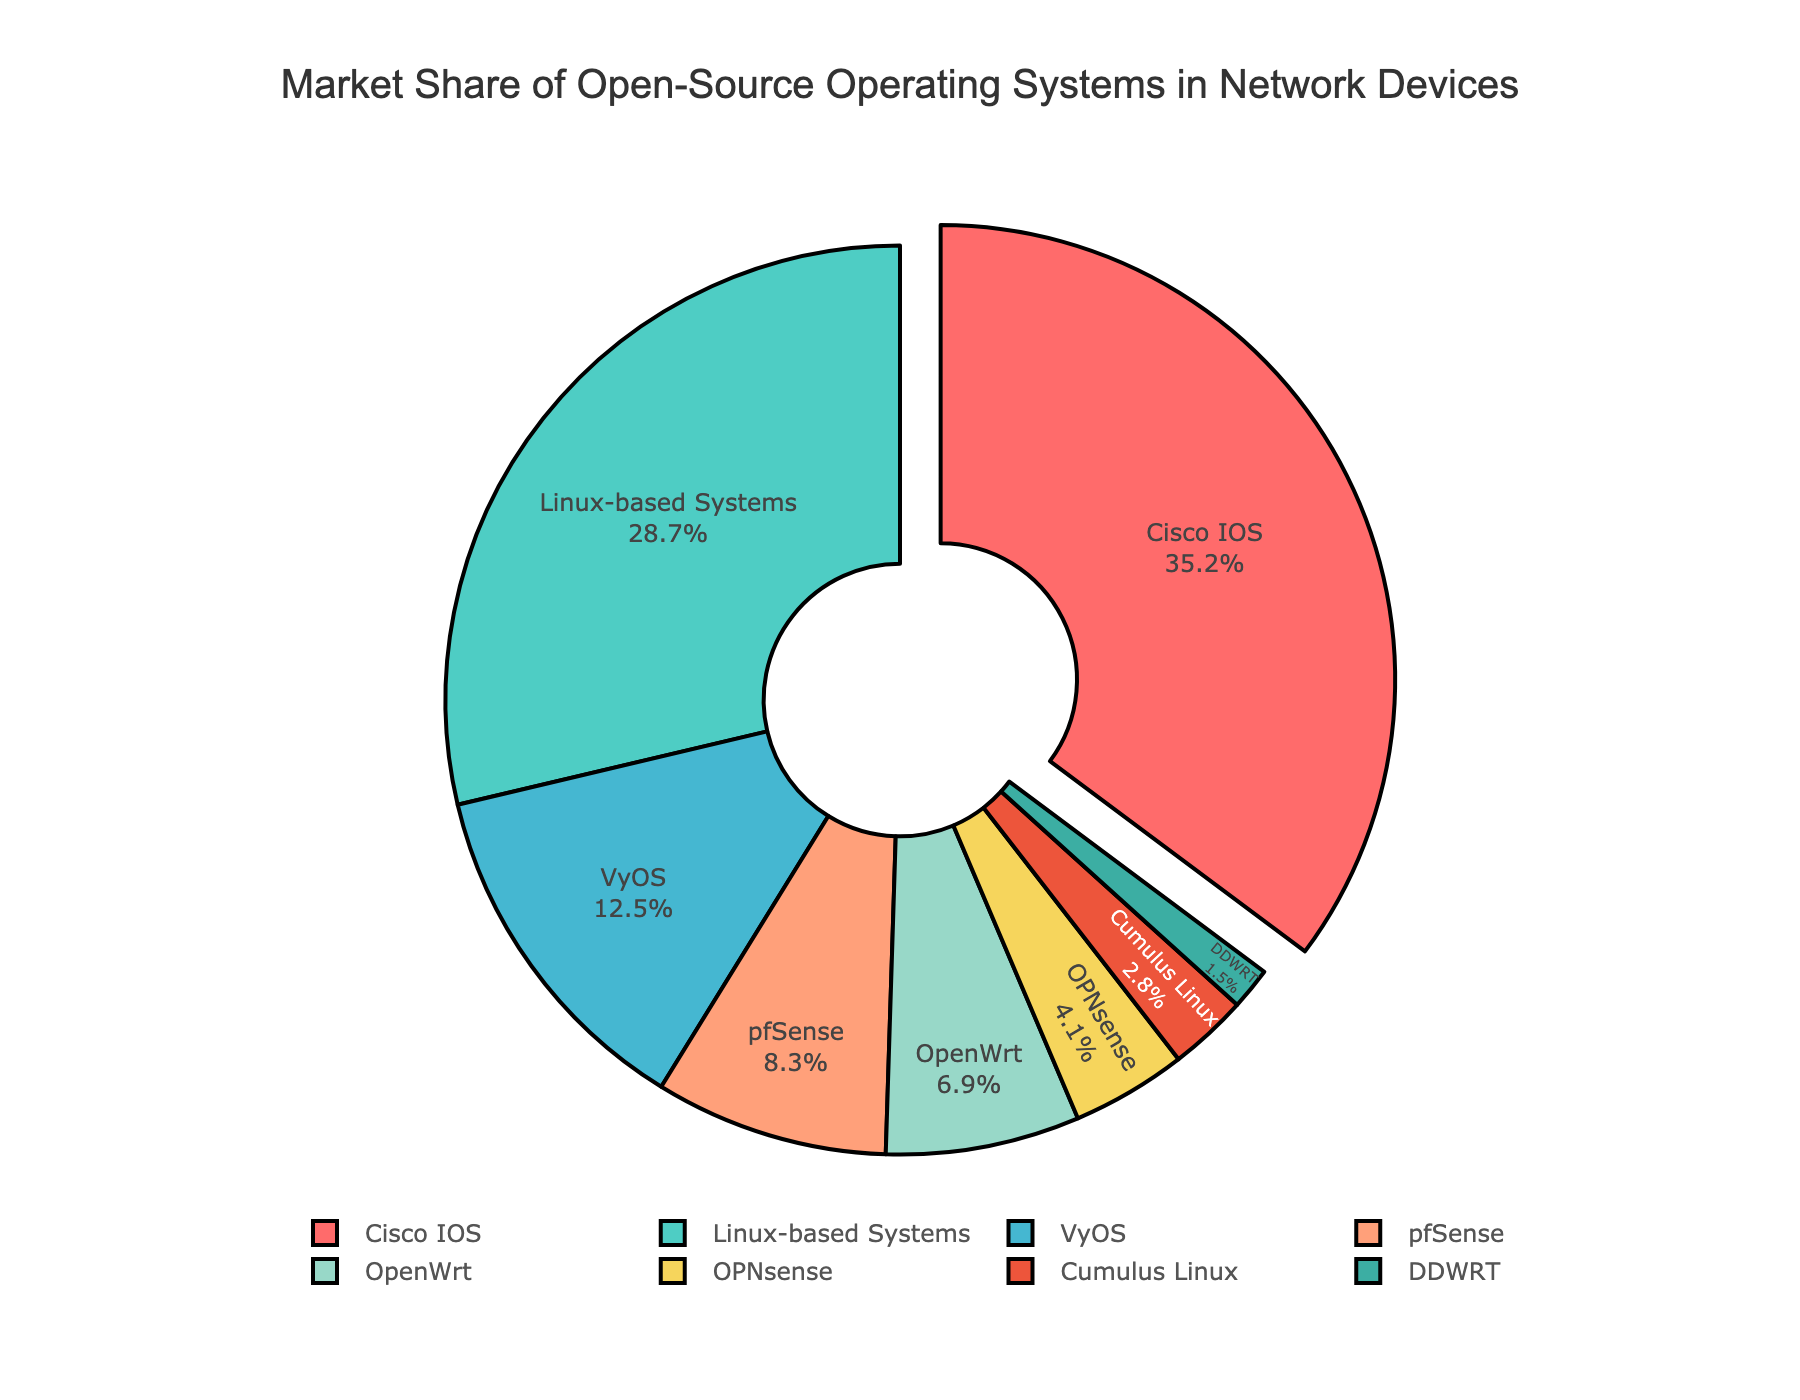What is the market share of the Linux-based Systems? The percentage value next to "Linux-based Systems" in the pie chart is 28.7%.
Answer: 28.7% Which operating system has the highest market share? The slice pulled out from the rest of the pie chart represents the operating system with the highest market share, which is Cisco IOS at 35.2%.
Answer: Cisco IOS What is the combined market share of VyOS and pfSense? To find the combined market share, add the percentages of VyOS (12.5%) and pfSense (8.3%). This gives 12.5 + 8.3 = 20.8%.
Answer: 20.8% Are there more operating systems with a market share greater than or less than 10%? There are three slices with market shares greater than 10% (Cisco IOS, Linux-based Systems, and VyOS) and five slices with market shares less than 10%.
Answer: Less than 10% Which operating system has a larger market share: OpenWrt or OPNsense? Compare the percentages of OpenWrt (6.9%) and OPNsense (4.1%) as shown in the pie chart. Since 6.9 > 4.1, OpenWrt has a larger market share.
Answer: OpenWrt What is the difference in market share between the operating system with the highest share and the operating system with the lowest share? Subtract the market share of the lowest (1.5% for DDWRT) from the highest (35.2% for Cisco IOS), which is 35.2 - 1.5 = 33.7%.
Answer: 33.7% What is the average market share of the listed operating systems? To find the average, add all the market shares (35.2 + 28.7 + 12.5 + 8.3 + 6.9 + 4.1 + 2.8 + 1.5 = 100) and divide by the number of operating systems (8). So, 100 / 8 = 12.5%.
Answer: 12.5% What color represents Cumulus Linux, and what is its market share? The pie chart shows Cumulus Linux in a lighter blue color, and its market share is 2.8%.
Answer: Light blue, 2.8% Is the sum of the market shares of OPNsense and DDWRT greater than 5%? Add the market shares of OPNsense (4.1%) and DDWRT (1.5%) to get 4.1 + 1.5 = 5.6%, which is greater than 5%.
Answer: Yes 